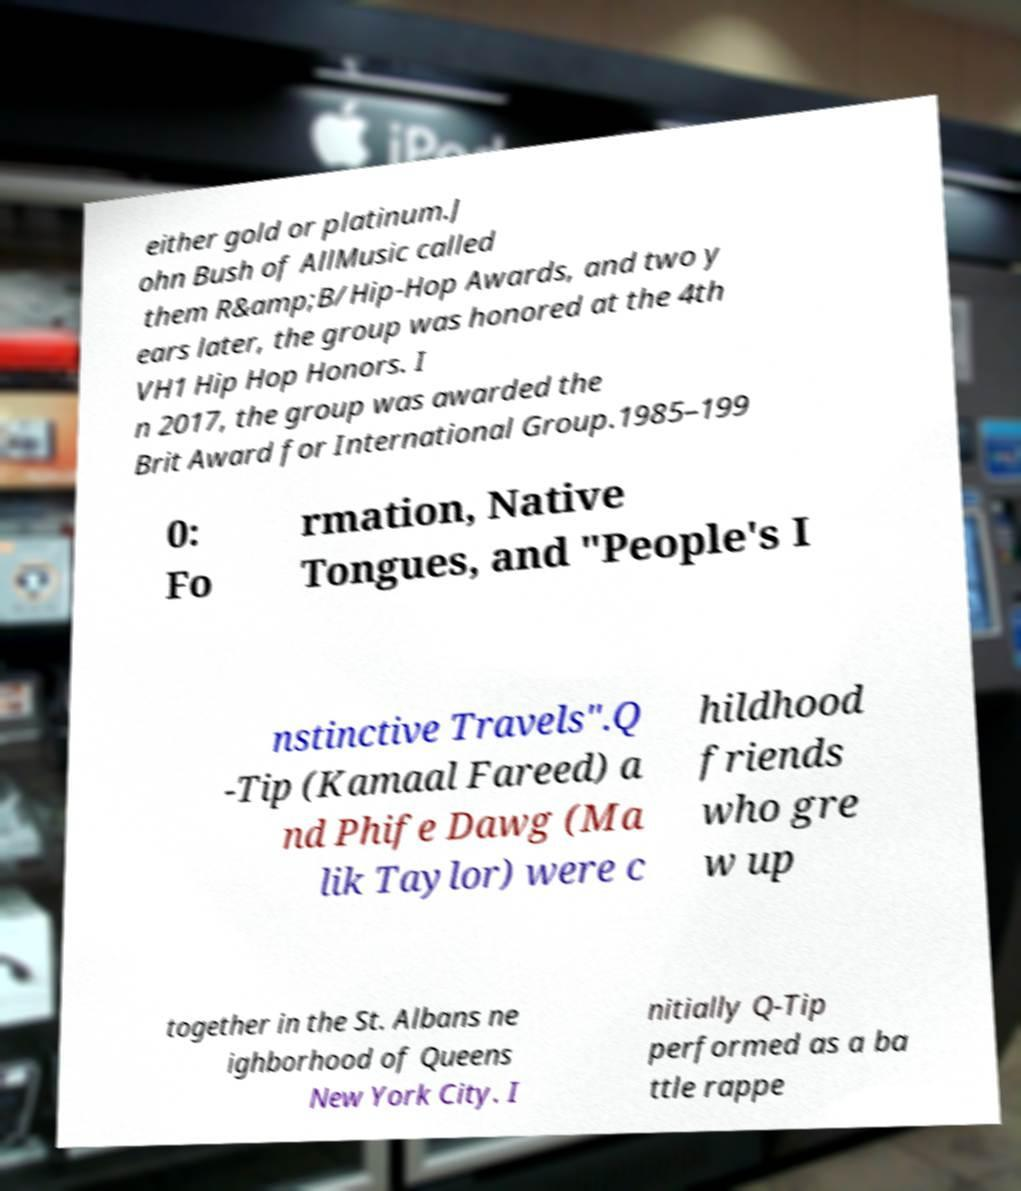Please identify and transcribe the text found in this image. either gold or platinum.J ohn Bush of AllMusic called them R&amp;B/Hip-Hop Awards, and two y ears later, the group was honored at the 4th VH1 Hip Hop Honors. I n 2017, the group was awarded the Brit Award for International Group.1985–199 0: Fo rmation, Native Tongues, and "People's I nstinctive Travels".Q -Tip (Kamaal Fareed) a nd Phife Dawg (Ma lik Taylor) were c hildhood friends who gre w up together in the St. Albans ne ighborhood of Queens New York City. I nitially Q-Tip performed as a ba ttle rappe 